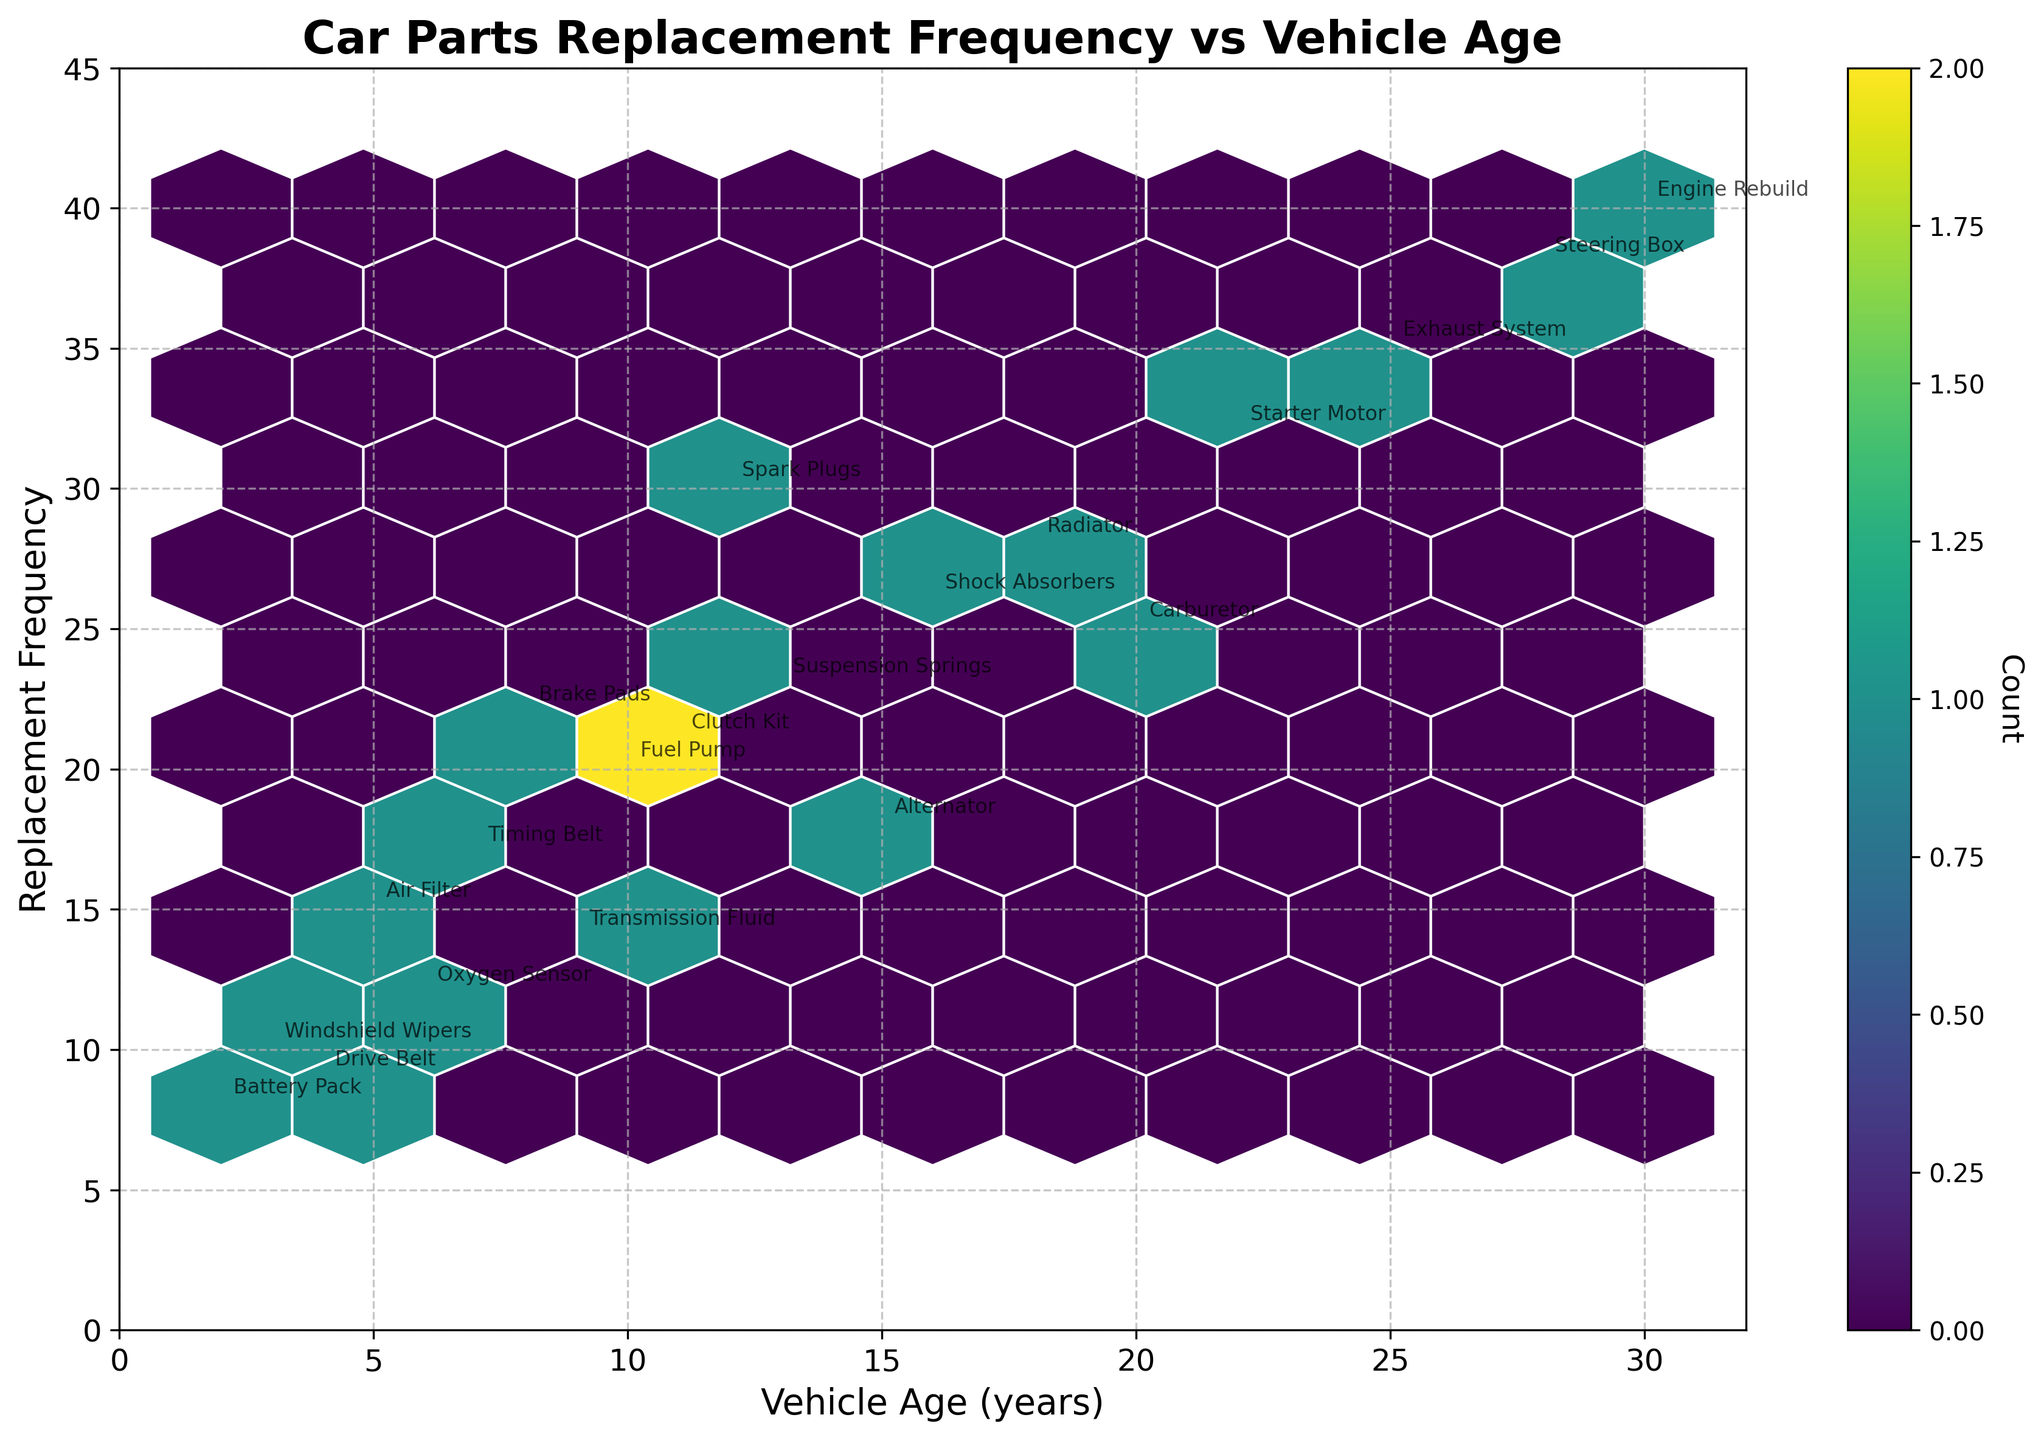What's the title of the plot? The title is usually at the top of the plot and it describes the main focus.
Answer: Car Parts Replacement Frequency vs Vehicle Age What are the labels on the x and y axes? The x-axis label indicates the 'Vehicle Age (years)' while the y-axis label shows 'Replacement Frequency'. These are usually found directly beside the respective axes.
Answer: Vehicle Age (years); Replacement Frequency How does the frequency of parts replacement change with vehicle age? Observing the hexbin plot, higher frequencies are typically associated with moderate to higher vehicle ages.
Answer: Increases with age Which car part has the highest replacement frequency and what's the vehicle age? Look at the annotations on the plot and find the highest point on the y-axis, then check its label.
Answer: Engine Rebuild at 30 years Are older vehicles more likely to have a wider variety of parts being replaced? By examining the distribution and annotations of the parts in relation to vehicle age, notice if older vehicles cover more parts.
Answer: Yes What is the color scheme used on the hexbin plot and what does it represent? The color scheme, indicated by the color bar, usually ranges from light to dark shades of a single color representing the count of data points in each bin.
Answer: Viridis; Count Which part has a replacement frequency of 10 and what is the vehicle age? Locate the point annotated with the frequency of 10 on the y-axis and check its corresponding label.
Answer: Windshield Wipers; 3 years How does the replacement frequency of parts for vehicles aged 10 years compare to those aged 20 years? Identify the points that correspond to these vehicle ages and compare their replacement frequencies.
Answer: Lower at 10 years than at 20 years What is the frequency range for the plotted data? Observe the lowest and highest points along the y-axis to determine the range.
Answer: 8 to 40 Which car part associated with a 22-year-old vehicle has the highest replacement frequency? Look for annotations around the 22-year mark and identify the highest frequency.
Answer: Starter Motor 